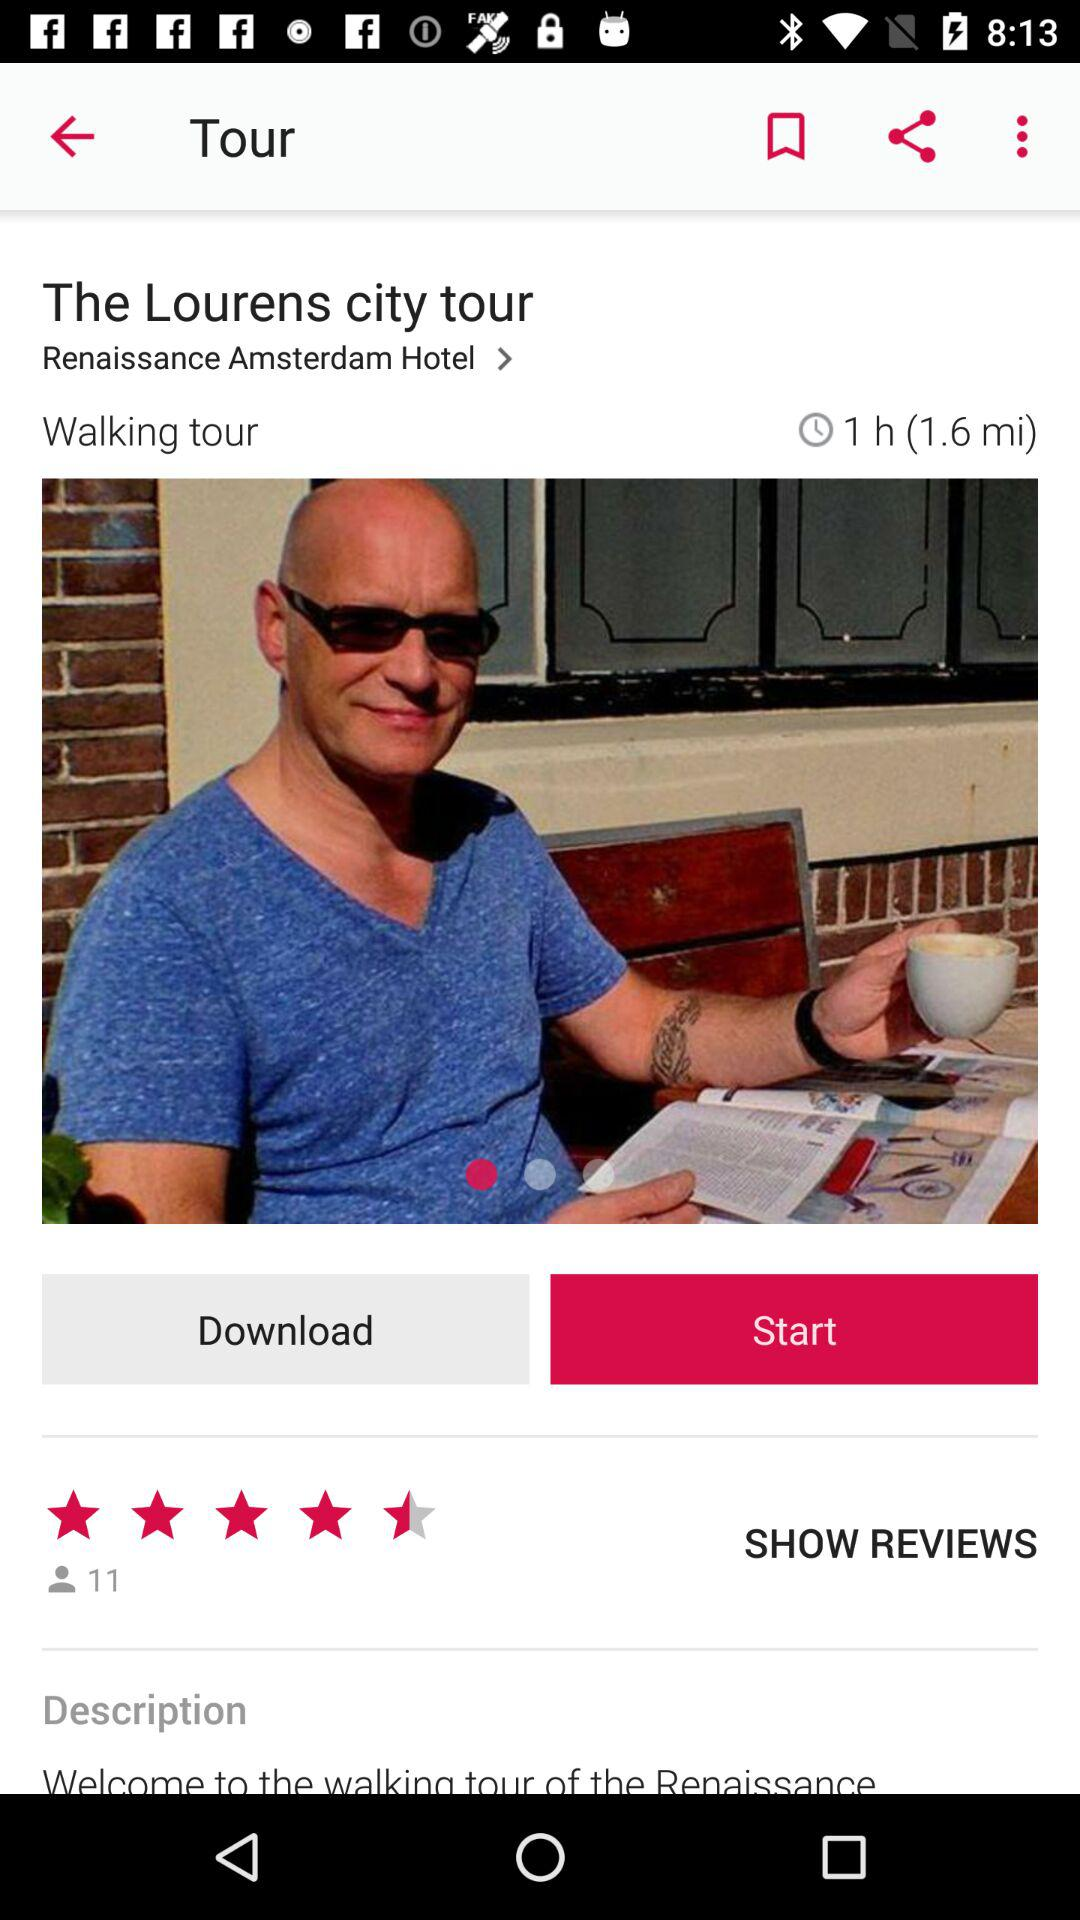How many reviews does the tour have?
Answer the question using a single word or phrase. 11 